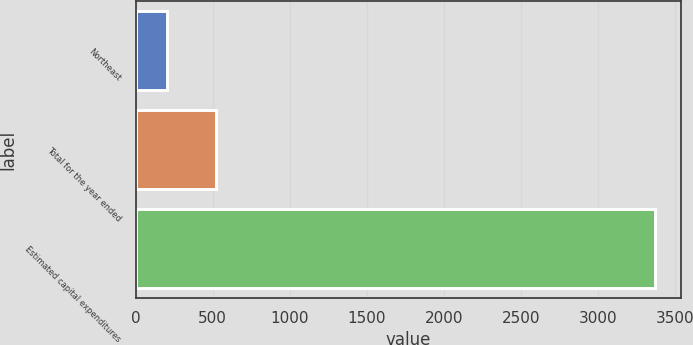Convert chart. <chart><loc_0><loc_0><loc_500><loc_500><bar_chart><fcel>Northeast<fcel>Total for the year ended<fcel>Estimated capital expenditures<nl><fcel>206<fcel>522.2<fcel>3368<nl></chart> 